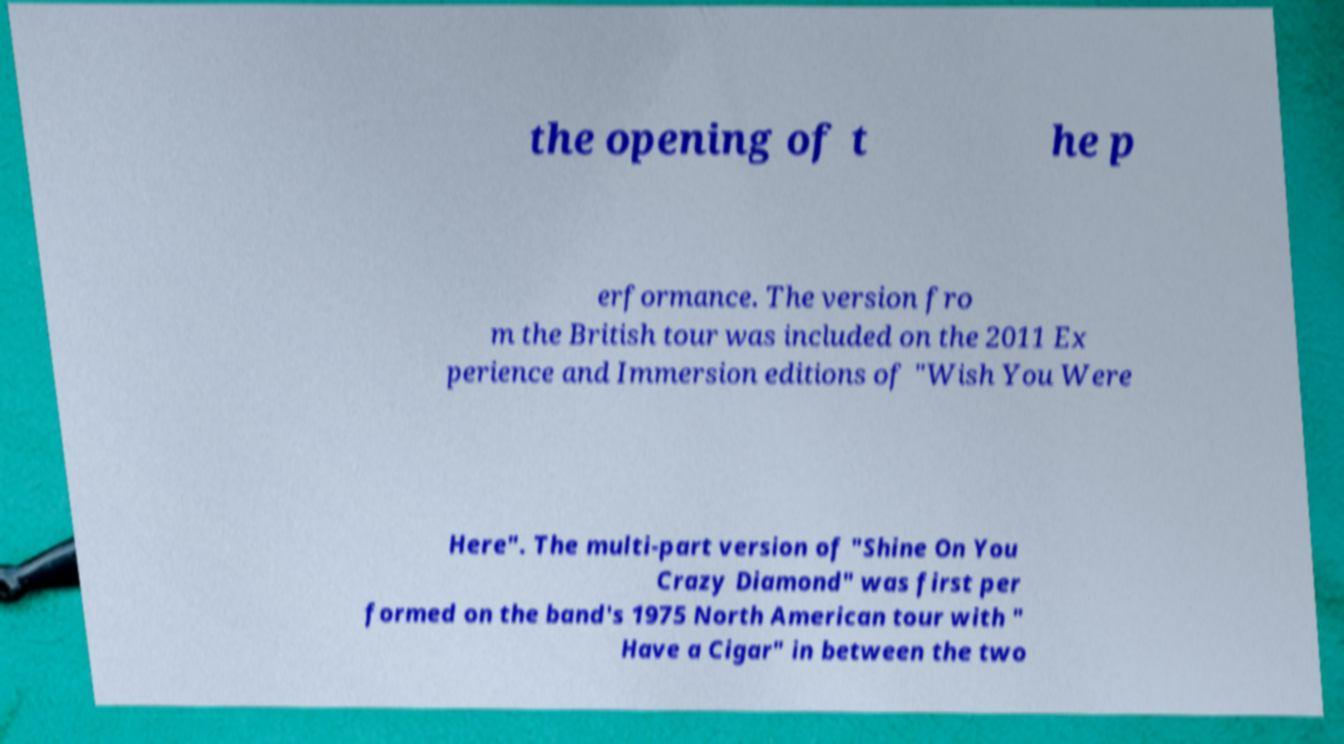There's text embedded in this image that I need extracted. Can you transcribe it verbatim? the opening of t he p erformance. The version fro m the British tour was included on the 2011 Ex perience and Immersion editions of "Wish You Were Here". The multi-part version of "Shine On You Crazy Diamond" was first per formed on the band's 1975 North American tour with " Have a Cigar" in between the two 